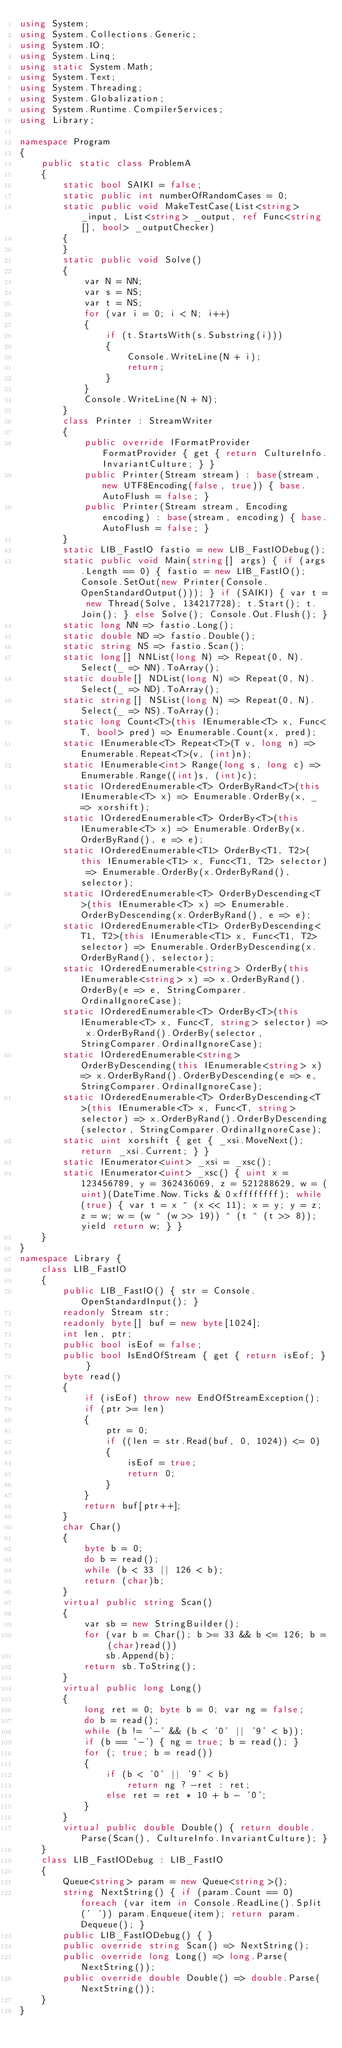Convert code to text. <code><loc_0><loc_0><loc_500><loc_500><_C#_>using System;
using System.Collections.Generic;
using System.IO;
using System.Linq;
using static System.Math;
using System.Text;
using System.Threading;
using System.Globalization;
using System.Runtime.CompilerServices;
using Library;

namespace Program
{
    public static class ProblemA
    {
        static bool SAIKI = false;
        static public int numberOfRandomCases = 0;
        static public void MakeTestCase(List<string> _input, List<string> _output, ref Func<string[], bool> _outputChecker)
        {
        }
        static public void Solve()
        {
            var N = NN;
            var s = NS;
            var t = NS;
            for (var i = 0; i < N; i++)
            {
                if (t.StartsWith(s.Substring(i)))
                {
                    Console.WriteLine(N + i);
                    return;
                }
            }
            Console.WriteLine(N + N);
        }
        class Printer : StreamWriter
        {
            public override IFormatProvider FormatProvider { get { return CultureInfo.InvariantCulture; } }
            public Printer(Stream stream) : base(stream, new UTF8Encoding(false, true)) { base.AutoFlush = false; }
            public Printer(Stream stream, Encoding encoding) : base(stream, encoding) { base.AutoFlush = false; }
        }
        static LIB_FastIO fastio = new LIB_FastIODebug();
        static public void Main(string[] args) { if (args.Length == 0) { fastio = new LIB_FastIO(); Console.SetOut(new Printer(Console.OpenStandardOutput())); } if (SAIKI) { var t = new Thread(Solve, 134217728); t.Start(); t.Join(); } else Solve(); Console.Out.Flush(); }
        static long NN => fastio.Long();
        static double ND => fastio.Double();
        static string NS => fastio.Scan();
        static long[] NNList(long N) => Repeat(0, N).Select(_ => NN).ToArray();
        static double[] NDList(long N) => Repeat(0, N).Select(_ => ND).ToArray();
        static string[] NSList(long N) => Repeat(0, N).Select(_ => NS).ToArray();
        static long Count<T>(this IEnumerable<T> x, Func<T, bool> pred) => Enumerable.Count(x, pred);
        static IEnumerable<T> Repeat<T>(T v, long n) => Enumerable.Repeat<T>(v, (int)n);
        static IEnumerable<int> Range(long s, long c) => Enumerable.Range((int)s, (int)c);
        static IOrderedEnumerable<T> OrderByRand<T>(this IEnumerable<T> x) => Enumerable.OrderBy(x, _ => xorshift);
        static IOrderedEnumerable<T> OrderBy<T>(this IEnumerable<T> x) => Enumerable.OrderBy(x.OrderByRand(), e => e);
        static IOrderedEnumerable<T1> OrderBy<T1, T2>(this IEnumerable<T1> x, Func<T1, T2> selector) => Enumerable.OrderBy(x.OrderByRand(), selector);
        static IOrderedEnumerable<T> OrderByDescending<T>(this IEnumerable<T> x) => Enumerable.OrderByDescending(x.OrderByRand(), e => e);
        static IOrderedEnumerable<T1> OrderByDescending<T1, T2>(this IEnumerable<T1> x, Func<T1, T2> selector) => Enumerable.OrderByDescending(x.OrderByRand(), selector);
        static IOrderedEnumerable<string> OrderBy(this IEnumerable<string> x) => x.OrderByRand().OrderBy(e => e, StringComparer.OrdinalIgnoreCase);
        static IOrderedEnumerable<T> OrderBy<T>(this IEnumerable<T> x, Func<T, string> selector) => x.OrderByRand().OrderBy(selector, StringComparer.OrdinalIgnoreCase);
        static IOrderedEnumerable<string> OrderByDescending(this IEnumerable<string> x) => x.OrderByRand().OrderByDescending(e => e, StringComparer.OrdinalIgnoreCase);
        static IOrderedEnumerable<T> OrderByDescending<T>(this IEnumerable<T> x, Func<T, string> selector) => x.OrderByRand().OrderByDescending(selector, StringComparer.OrdinalIgnoreCase);
        static uint xorshift { get { _xsi.MoveNext(); return _xsi.Current; } }
        static IEnumerator<uint> _xsi = _xsc();
        static IEnumerator<uint> _xsc() { uint x = 123456789, y = 362436069, z = 521288629, w = (uint)(DateTime.Now.Ticks & 0xffffffff); while (true) { var t = x ^ (x << 11); x = y; y = z; z = w; w = (w ^ (w >> 19)) ^ (t ^ (t >> 8)); yield return w; } }
    }
}
namespace Library {
    class LIB_FastIO
    {
        public LIB_FastIO() { str = Console.OpenStandardInput(); }
        readonly Stream str;
        readonly byte[] buf = new byte[1024];
        int len, ptr;
        public bool isEof = false;
        public bool IsEndOfStream { get { return isEof; } }
        byte read()
        {
            if (isEof) throw new EndOfStreamException();
            if (ptr >= len)
            {
                ptr = 0;
                if ((len = str.Read(buf, 0, 1024)) <= 0)
                {
                    isEof = true;
                    return 0;
                }
            }
            return buf[ptr++];
        }
        char Char()
        {
            byte b = 0;
            do b = read();
            while (b < 33 || 126 < b);
            return (char)b;
        }
        virtual public string Scan()
        {
            var sb = new StringBuilder();
            for (var b = Char(); b >= 33 && b <= 126; b = (char)read())
                sb.Append(b);
            return sb.ToString();
        }
        virtual public long Long()
        {
            long ret = 0; byte b = 0; var ng = false;
            do b = read();
            while (b != '-' && (b < '0' || '9' < b));
            if (b == '-') { ng = true; b = read(); }
            for (; true; b = read())
            {
                if (b < '0' || '9' < b)
                    return ng ? -ret : ret;
                else ret = ret * 10 + b - '0';
            }
        }
        virtual public double Double() { return double.Parse(Scan(), CultureInfo.InvariantCulture); }
    }
    class LIB_FastIODebug : LIB_FastIO
    {
        Queue<string> param = new Queue<string>();
        string NextString() { if (param.Count == 0) foreach (var item in Console.ReadLine().Split(' ')) param.Enqueue(item); return param.Dequeue(); }
        public LIB_FastIODebug() { }
        public override string Scan() => NextString();
        public override long Long() => long.Parse(NextString());
        public override double Double() => double.Parse(NextString());
    }
}
</code> 